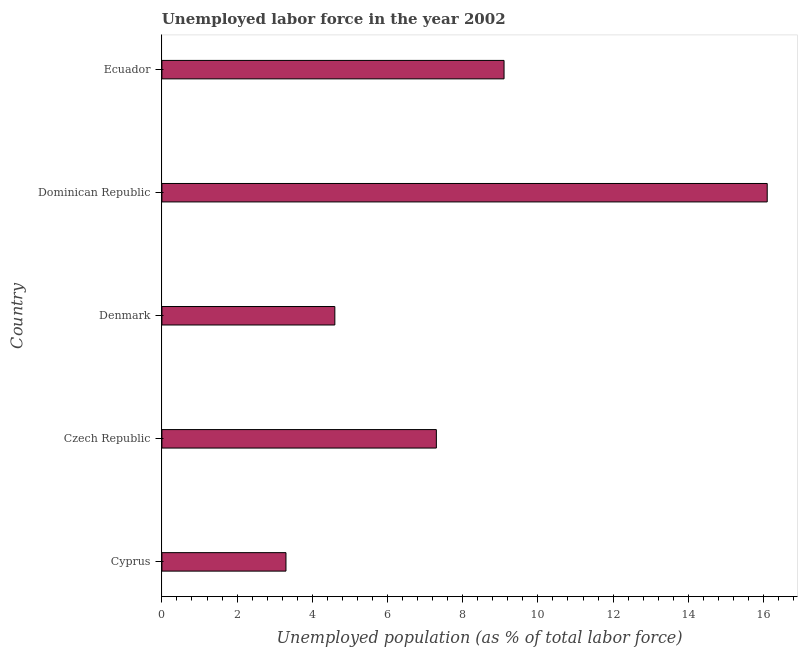Does the graph contain any zero values?
Make the answer very short. No. Does the graph contain grids?
Give a very brief answer. No. What is the title of the graph?
Your response must be concise. Unemployed labor force in the year 2002. What is the label or title of the X-axis?
Provide a short and direct response. Unemployed population (as % of total labor force). What is the total unemployed population in Ecuador?
Your answer should be compact. 9.1. Across all countries, what is the maximum total unemployed population?
Provide a succinct answer. 16.1. Across all countries, what is the minimum total unemployed population?
Your answer should be compact. 3.3. In which country was the total unemployed population maximum?
Provide a succinct answer. Dominican Republic. In which country was the total unemployed population minimum?
Your response must be concise. Cyprus. What is the sum of the total unemployed population?
Make the answer very short. 40.4. What is the difference between the total unemployed population in Denmark and Ecuador?
Provide a short and direct response. -4.5. What is the average total unemployed population per country?
Your answer should be compact. 8.08. What is the median total unemployed population?
Your answer should be compact. 7.3. What is the ratio of the total unemployed population in Dominican Republic to that in Ecuador?
Keep it short and to the point. 1.77. Is the total unemployed population in Czech Republic less than that in Dominican Republic?
Give a very brief answer. Yes. Is the difference between the total unemployed population in Cyprus and Ecuador greater than the difference between any two countries?
Provide a succinct answer. No. What is the difference between the highest and the second highest total unemployed population?
Ensure brevity in your answer.  7. What is the difference between the highest and the lowest total unemployed population?
Make the answer very short. 12.8. Are all the bars in the graph horizontal?
Ensure brevity in your answer.  Yes. What is the Unemployed population (as % of total labor force) in Cyprus?
Provide a succinct answer. 3.3. What is the Unemployed population (as % of total labor force) in Czech Republic?
Provide a succinct answer. 7.3. What is the Unemployed population (as % of total labor force) of Denmark?
Your response must be concise. 4.6. What is the Unemployed population (as % of total labor force) of Dominican Republic?
Provide a short and direct response. 16.1. What is the Unemployed population (as % of total labor force) of Ecuador?
Provide a short and direct response. 9.1. What is the difference between the Unemployed population (as % of total labor force) in Cyprus and Dominican Republic?
Your response must be concise. -12.8. What is the difference between the Unemployed population (as % of total labor force) in Cyprus and Ecuador?
Provide a succinct answer. -5.8. What is the difference between the Unemployed population (as % of total labor force) in Czech Republic and Denmark?
Your answer should be very brief. 2.7. What is the difference between the Unemployed population (as % of total labor force) in Czech Republic and Dominican Republic?
Ensure brevity in your answer.  -8.8. What is the difference between the Unemployed population (as % of total labor force) in Czech Republic and Ecuador?
Ensure brevity in your answer.  -1.8. What is the difference between the Unemployed population (as % of total labor force) in Denmark and Ecuador?
Ensure brevity in your answer.  -4.5. What is the ratio of the Unemployed population (as % of total labor force) in Cyprus to that in Czech Republic?
Your answer should be compact. 0.45. What is the ratio of the Unemployed population (as % of total labor force) in Cyprus to that in Denmark?
Provide a succinct answer. 0.72. What is the ratio of the Unemployed population (as % of total labor force) in Cyprus to that in Dominican Republic?
Your response must be concise. 0.2. What is the ratio of the Unemployed population (as % of total labor force) in Cyprus to that in Ecuador?
Offer a terse response. 0.36. What is the ratio of the Unemployed population (as % of total labor force) in Czech Republic to that in Denmark?
Provide a short and direct response. 1.59. What is the ratio of the Unemployed population (as % of total labor force) in Czech Republic to that in Dominican Republic?
Your answer should be very brief. 0.45. What is the ratio of the Unemployed population (as % of total labor force) in Czech Republic to that in Ecuador?
Offer a very short reply. 0.8. What is the ratio of the Unemployed population (as % of total labor force) in Denmark to that in Dominican Republic?
Keep it short and to the point. 0.29. What is the ratio of the Unemployed population (as % of total labor force) in Denmark to that in Ecuador?
Provide a short and direct response. 0.51. What is the ratio of the Unemployed population (as % of total labor force) in Dominican Republic to that in Ecuador?
Your response must be concise. 1.77. 